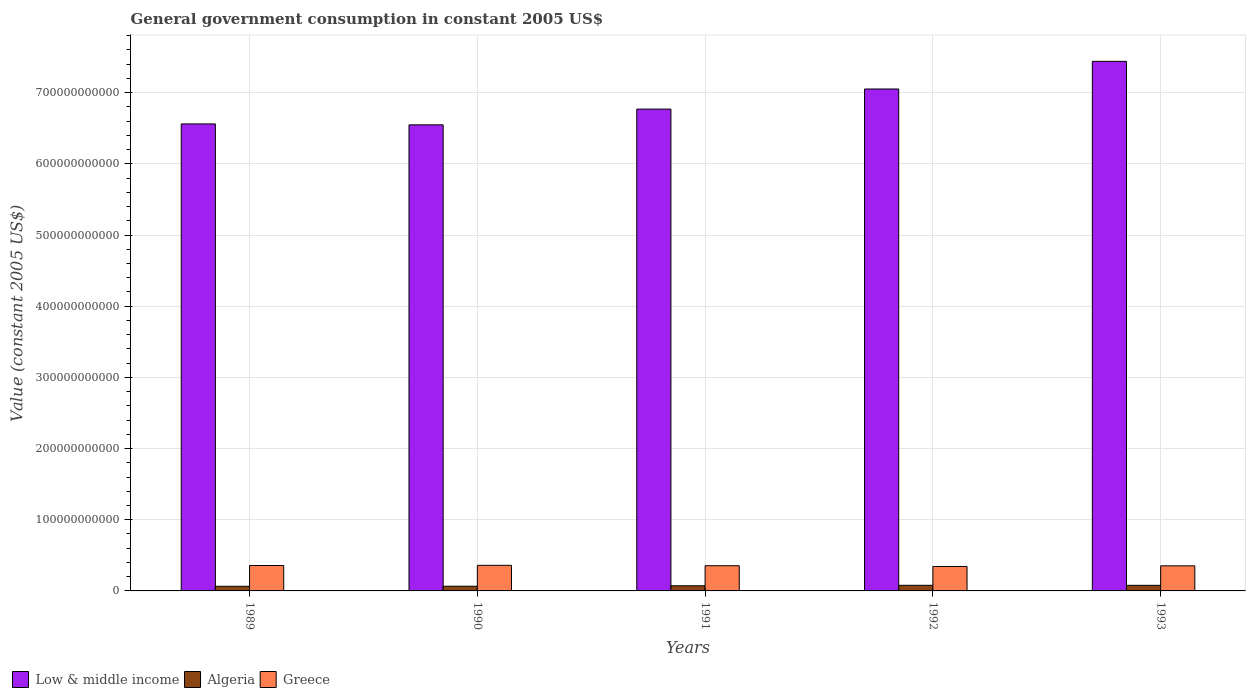Are the number of bars per tick equal to the number of legend labels?
Make the answer very short. Yes. What is the government conusmption in Low & middle income in 1990?
Offer a terse response. 6.55e+11. Across all years, what is the maximum government conusmption in Algeria?
Keep it short and to the point. 7.89e+09. Across all years, what is the minimum government conusmption in Greece?
Your answer should be compact. 3.43e+1. In which year was the government conusmption in Greece maximum?
Provide a short and direct response. 1990. What is the total government conusmption in Algeria in the graph?
Give a very brief answer. 3.61e+1. What is the difference between the government conusmption in Low & middle income in 1989 and that in 1991?
Provide a short and direct response. -2.08e+1. What is the difference between the government conusmption in Algeria in 1993 and the government conusmption in Greece in 1989?
Give a very brief answer. -2.79e+1. What is the average government conusmption in Algeria per year?
Ensure brevity in your answer.  7.22e+09. In the year 1992, what is the difference between the government conusmption in Low & middle income and government conusmption in Algeria?
Keep it short and to the point. 6.97e+11. In how many years, is the government conusmption in Greece greater than 620000000000 US$?
Your response must be concise. 0. What is the ratio of the government conusmption in Algeria in 1989 to that in 1991?
Ensure brevity in your answer.  0.9. Is the difference between the government conusmption in Low & middle income in 1992 and 1993 greater than the difference between the government conusmption in Algeria in 1992 and 1993?
Your response must be concise. No. What is the difference between the highest and the second highest government conusmption in Algeria?
Your response must be concise. 3.16e+07. What is the difference between the highest and the lowest government conusmption in Algeria?
Provide a short and direct response. 1.40e+09. In how many years, is the government conusmption in Low & middle income greater than the average government conusmption in Low & middle income taken over all years?
Provide a short and direct response. 2. What does the 2nd bar from the right in 1991 represents?
Offer a terse response. Algeria. Is it the case that in every year, the sum of the government conusmption in Greece and government conusmption in Algeria is greater than the government conusmption in Low & middle income?
Ensure brevity in your answer.  No. How many bars are there?
Offer a very short reply. 15. How many years are there in the graph?
Keep it short and to the point. 5. What is the difference between two consecutive major ticks on the Y-axis?
Offer a terse response. 1.00e+11. Where does the legend appear in the graph?
Your response must be concise. Bottom left. How many legend labels are there?
Ensure brevity in your answer.  3. How are the legend labels stacked?
Keep it short and to the point. Horizontal. What is the title of the graph?
Provide a short and direct response. General government consumption in constant 2005 US$. Does "Zimbabwe" appear as one of the legend labels in the graph?
Your response must be concise. No. What is the label or title of the Y-axis?
Your answer should be very brief. Value (constant 2005 US$). What is the Value (constant 2005 US$) of Low & middle income in 1989?
Your answer should be very brief. 6.56e+11. What is the Value (constant 2005 US$) in Algeria in 1989?
Give a very brief answer. 6.50e+09. What is the Value (constant 2005 US$) in Greece in 1989?
Offer a very short reply. 3.57e+1. What is the Value (constant 2005 US$) in Low & middle income in 1990?
Offer a very short reply. 6.55e+11. What is the Value (constant 2005 US$) of Algeria in 1990?
Ensure brevity in your answer.  6.60e+09. What is the Value (constant 2005 US$) of Greece in 1990?
Your answer should be compact. 3.59e+1. What is the Value (constant 2005 US$) in Low & middle income in 1991?
Offer a terse response. 6.77e+11. What is the Value (constant 2005 US$) in Algeria in 1991?
Your answer should be compact. 7.22e+09. What is the Value (constant 2005 US$) in Greece in 1991?
Your answer should be very brief. 3.54e+1. What is the Value (constant 2005 US$) in Low & middle income in 1992?
Provide a succinct answer. 7.05e+11. What is the Value (constant 2005 US$) of Algeria in 1992?
Provide a succinct answer. 7.89e+09. What is the Value (constant 2005 US$) of Greece in 1992?
Give a very brief answer. 3.43e+1. What is the Value (constant 2005 US$) of Low & middle income in 1993?
Make the answer very short. 7.44e+11. What is the Value (constant 2005 US$) in Algeria in 1993?
Keep it short and to the point. 7.86e+09. What is the Value (constant 2005 US$) of Greece in 1993?
Your answer should be compact. 3.52e+1. Across all years, what is the maximum Value (constant 2005 US$) in Low & middle income?
Ensure brevity in your answer.  7.44e+11. Across all years, what is the maximum Value (constant 2005 US$) of Algeria?
Give a very brief answer. 7.89e+09. Across all years, what is the maximum Value (constant 2005 US$) in Greece?
Keep it short and to the point. 3.59e+1. Across all years, what is the minimum Value (constant 2005 US$) in Low & middle income?
Your answer should be very brief. 6.55e+11. Across all years, what is the minimum Value (constant 2005 US$) of Algeria?
Ensure brevity in your answer.  6.50e+09. Across all years, what is the minimum Value (constant 2005 US$) of Greece?
Make the answer very short. 3.43e+1. What is the total Value (constant 2005 US$) in Low & middle income in the graph?
Provide a succinct answer. 3.44e+12. What is the total Value (constant 2005 US$) of Algeria in the graph?
Keep it short and to the point. 3.61e+1. What is the total Value (constant 2005 US$) in Greece in the graph?
Ensure brevity in your answer.  1.77e+11. What is the difference between the Value (constant 2005 US$) of Low & middle income in 1989 and that in 1990?
Your response must be concise. 1.29e+09. What is the difference between the Value (constant 2005 US$) in Algeria in 1989 and that in 1990?
Ensure brevity in your answer.  -9.75e+07. What is the difference between the Value (constant 2005 US$) in Greece in 1989 and that in 1990?
Give a very brief answer. -2.14e+08. What is the difference between the Value (constant 2005 US$) in Low & middle income in 1989 and that in 1991?
Ensure brevity in your answer.  -2.08e+1. What is the difference between the Value (constant 2005 US$) in Algeria in 1989 and that in 1991?
Provide a short and direct response. -7.24e+08. What is the difference between the Value (constant 2005 US$) of Greece in 1989 and that in 1991?
Offer a very short reply. 3.25e+08. What is the difference between the Value (constant 2005 US$) of Low & middle income in 1989 and that in 1992?
Your answer should be compact. -4.91e+1. What is the difference between the Value (constant 2005 US$) of Algeria in 1989 and that in 1992?
Offer a terse response. -1.40e+09. What is the difference between the Value (constant 2005 US$) in Greece in 1989 and that in 1992?
Offer a very short reply. 1.39e+09. What is the difference between the Value (constant 2005 US$) of Low & middle income in 1989 and that in 1993?
Your response must be concise. -8.79e+1. What is the difference between the Value (constant 2005 US$) of Algeria in 1989 and that in 1993?
Provide a succinct answer. -1.36e+09. What is the difference between the Value (constant 2005 US$) of Greece in 1989 and that in 1993?
Give a very brief answer. 4.94e+08. What is the difference between the Value (constant 2005 US$) in Low & middle income in 1990 and that in 1991?
Provide a short and direct response. -2.21e+1. What is the difference between the Value (constant 2005 US$) in Algeria in 1990 and that in 1991?
Offer a very short reply. -6.27e+08. What is the difference between the Value (constant 2005 US$) in Greece in 1990 and that in 1991?
Your response must be concise. 5.39e+08. What is the difference between the Value (constant 2005 US$) of Low & middle income in 1990 and that in 1992?
Ensure brevity in your answer.  -5.04e+1. What is the difference between the Value (constant 2005 US$) in Algeria in 1990 and that in 1992?
Offer a terse response. -1.30e+09. What is the difference between the Value (constant 2005 US$) in Greece in 1990 and that in 1992?
Make the answer very short. 1.60e+09. What is the difference between the Value (constant 2005 US$) of Low & middle income in 1990 and that in 1993?
Offer a terse response. -8.92e+1. What is the difference between the Value (constant 2005 US$) in Algeria in 1990 and that in 1993?
Your answer should be compact. -1.27e+09. What is the difference between the Value (constant 2005 US$) in Greece in 1990 and that in 1993?
Your response must be concise. 7.08e+08. What is the difference between the Value (constant 2005 US$) of Low & middle income in 1991 and that in 1992?
Your answer should be compact. -2.83e+1. What is the difference between the Value (constant 2005 US$) of Algeria in 1991 and that in 1992?
Your answer should be very brief. -6.72e+08. What is the difference between the Value (constant 2005 US$) of Greece in 1991 and that in 1992?
Give a very brief answer. 1.06e+09. What is the difference between the Value (constant 2005 US$) of Low & middle income in 1991 and that in 1993?
Ensure brevity in your answer.  -6.71e+1. What is the difference between the Value (constant 2005 US$) of Algeria in 1991 and that in 1993?
Keep it short and to the point. -6.40e+08. What is the difference between the Value (constant 2005 US$) of Greece in 1991 and that in 1993?
Offer a terse response. 1.69e+08. What is the difference between the Value (constant 2005 US$) of Low & middle income in 1992 and that in 1993?
Offer a terse response. -3.88e+1. What is the difference between the Value (constant 2005 US$) of Algeria in 1992 and that in 1993?
Make the answer very short. 3.16e+07. What is the difference between the Value (constant 2005 US$) of Greece in 1992 and that in 1993?
Make the answer very short. -8.93e+08. What is the difference between the Value (constant 2005 US$) in Low & middle income in 1989 and the Value (constant 2005 US$) in Algeria in 1990?
Your answer should be compact. 6.50e+11. What is the difference between the Value (constant 2005 US$) of Low & middle income in 1989 and the Value (constant 2005 US$) of Greece in 1990?
Ensure brevity in your answer.  6.20e+11. What is the difference between the Value (constant 2005 US$) in Algeria in 1989 and the Value (constant 2005 US$) in Greece in 1990?
Give a very brief answer. -2.94e+1. What is the difference between the Value (constant 2005 US$) of Low & middle income in 1989 and the Value (constant 2005 US$) of Algeria in 1991?
Provide a succinct answer. 6.49e+11. What is the difference between the Value (constant 2005 US$) of Low & middle income in 1989 and the Value (constant 2005 US$) of Greece in 1991?
Offer a very short reply. 6.21e+11. What is the difference between the Value (constant 2005 US$) of Algeria in 1989 and the Value (constant 2005 US$) of Greece in 1991?
Give a very brief answer. -2.89e+1. What is the difference between the Value (constant 2005 US$) in Low & middle income in 1989 and the Value (constant 2005 US$) in Algeria in 1992?
Your answer should be compact. 6.48e+11. What is the difference between the Value (constant 2005 US$) in Low & middle income in 1989 and the Value (constant 2005 US$) in Greece in 1992?
Offer a terse response. 6.22e+11. What is the difference between the Value (constant 2005 US$) of Algeria in 1989 and the Value (constant 2005 US$) of Greece in 1992?
Give a very brief answer. -2.78e+1. What is the difference between the Value (constant 2005 US$) of Low & middle income in 1989 and the Value (constant 2005 US$) of Algeria in 1993?
Make the answer very short. 6.48e+11. What is the difference between the Value (constant 2005 US$) of Low & middle income in 1989 and the Value (constant 2005 US$) of Greece in 1993?
Your response must be concise. 6.21e+11. What is the difference between the Value (constant 2005 US$) in Algeria in 1989 and the Value (constant 2005 US$) in Greece in 1993?
Your answer should be very brief. -2.87e+1. What is the difference between the Value (constant 2005 US$) in Low & middle income in 1990 and the Value (constant 2005 US$) in Algeria in 1991?
Your answer should be very brief. 6.48e+11. What is the difference between the Value (constant 2005 US$) in Low & middle income in 1990 and the Value (constant 2005 US$) in Greece in 1991?
Offer a terse response. 6.19e+11. What is the difference between the Value (constant 2005 US$) in Algeria in 1990 and the Value (constant 2005 US$) in Greece in 1991?
Your answer should be compact. -2.88e+1. What is the difference between the Value (constant 2005 US$) of Low & middle income in 1990 and the Value (constant 2005 US$) of Algeria in 1992?
Your response must be concise. 6.47e+11. What is the difference between the Value (constant 2005 US$) of Low & middle income in 1990 and the Value (constant 2005 US$) of Greece in 1992?
Give a very brief answer. 6.20e+11. What is the difference between the Value (constant 2005 US$) in Algeria in 1990 and the Value (constant 2005 US$) in Greece in 1992?
Keep it short and to the point. -2.78e+1. What is the difference between the Value (constant 2005 US$) in Low & middle income in 1990 and the Value (constant 2005 US$) in Algeria in 1993?
Offer a terse response. 6.47e+11. What is the difference between the Value (constant 2005 US$) in Low & middle income in 1990 and the Value (constant 2005 US$) in Greece in 1993?
Your answer should be compact. 6.20e+11. What is the difference between the Value (constant 2005 US$) in Algeria in 1990 and the Value (constant 2005 US$) in Greece in 1993?
Keep it short and to the point. -2.86e+1. What is the difference between the Value (constant 2005 US$) in Low & middle income in 1991 and the Value (constant 2005 US$) in Algeria in 1992?
Offer a very short reply. 6.69e+11. What is the difference between the Value (constant 2005 US$) in Low & middle income in 1991 and the Value (constant 2005 US$) in Greece in 1992?
Your response must be concise. 6.43e+11. What is the difference between the Value (constant 2005 US$) in Algeria in 1991 and the Value (constant 2005 US$) in Greece in 1992?
Make the answer very short. -2.71e+1. What is the difference between the Value (constant 2005 US$) of Low & middle income in 1991 and the Value (constant 2005 US$) of Algeria in 1993?
Your response must be concise. 6.69e+11. What is the difference between the Value (constant 2005 US$) of Low & middle income in 1991 and the Value (constant 2005 US$) of Greece in 1993?
Offer a very short reply. 6.42e+11. What is the difference between the Value (constant 2005 US$) of Algeria in 1991 and the Value (constant 2005 US$) of Greece in 1993?
Offer a very short reply. -2.80e+1. What is the difference between the Value (constant 2005 US$) in Low & middle income in 1992 and the Value (constant 2005 US$) in Algeria in 1993?
Offer a very short reply. 6.97e+11. What is the difference between the Value (constant 2005 US$) of Low & middle income in 1992 and the Value (constant 2005 US$) of Greece in 1993?
Ensure brevity in your answer.  6.70e+11. What is the difference between the Value (constant 2005 US$) in Algeria in 1992 and the Value (constant 2005 US$) in Greece in 1993?
Your answer should be compact. -2.73e+1. What is the average Value (constant 2005 US$) in Low & middle income per year?
Keep it short and to the point. 6.87e+11. What is the average Value (constant 2005 US$) in Algeria per year?
Provide a short and direct response. 7.22e+09. What is the average Value (constant 2005 US$) of Greece per year?
Give a very brief answer. 3.53e+1. In the year 1989, what is the difference between the Value (constant 2005 US$) in Low & middle income and Value (constant 2005 US$) in Algeria?
Make the answer very short. 6.50e+11. In the year 1989, what is the difference between the Value (constant 2005 US$) of Low & middle income and Value (constant 2005 US$) of Greece?
Ensure brevity in your answer.  6.20e+11. In the year 1989, what is the difference between the Value (constant 2005 US$) in Algeria and Value (constant 2005 US$) in Greece?
Your response must be concise. -2.92e+1. In the year 1990, what is the difference between the Value (constant 2005 US$) in Low & middle income and Value (constant 2005 US$) in Algeria?
Provide a short and direct response. 6.48e+11. In the year 1990, what is the difference between the Value (constant 2005 US$) of Low & middle income and Value (constant 2005 US$) of Greece?
Your response must be concise. 6.19e+11. In the year 1990, what is the difference between the Value (constant 2005 US$) of Algeria and Value (constant 2005 US$) of Greece?
Your answer should be very brief. -2.94e+1. In the year 1991, what is the difference between the Value (constant 2005 US$) of Low & middle income and Value (constant 2005 US$) of Algeria?
Provide a succinct answer. 6.70e+11. In the year 1991, what is the difference between the Value (constant 2005 US$) of Low & middle income and Value (constant 2005 US$) of Greece?
Your response must be concise. 6.42e+11. In the year 1991, what is the difference between the Value (constant 2005 US$) in Algeria and Value (constant 2005 US$) in Greece?
Provide a succinct answer. -2.82e+1. In the year 1992, what is the difference between the Value (constant 2005 US$) in Low & middle income and Value (constant 2005 US$) in Algeria?
Ensure brevity in your answer.  6.97e+11. In the year 1992, what is the difference between the Value (constant 2005 US$) in Low & middle income and Value (constant 2005 US$) in Greece?
Keep it short and to the point. 6.71e+11. In the year 1992, what is the difference between the Value (constant 2005 US$) of Algeria and Value (constant 2005 US$) of Greece?
Keep it short and to the point. -2.65e+1. In the year 1993, what is the difference between the Value (constant 2005 US$) of Low & middle income and Value (constant 2005 US$) of Algeria?
Offer a very short reply. 7.36e+11. In the year 1993, what is the difference between the Value (constant 2005 US$) in Low & middle income and Value (constant 2005 US$) in Greece?
Give a very brief answer. 7.09e+11. In the year 1993, what is the difference between the Value (constant 2005 US$) of Algeria and Value (constant 2005 US$) of Greece?
Provide a succinct answer. -2.74e+1. What is the ratio of the Value (constant 2005 US$) of Low & middle income in 1989 to that in 1990?
Give a very brief answer. 1. What is the ratio of the Value (constant 2005 US$) in Algeria in 1989 to that in 1990?
Offer a very short reply. 0.99. What is the ratio of the Value (constant 2005 US$) in Greece in 1989 to that in 1990?
Provide a succinct answer. 0.99. What is the ratio of the Value (constant 2005 US$) of Low & middle income in 1989 to that in 1991?
Offer a terse response. 0.97. What is the ratio of the Value (constant 2005 US$) in Algeria in 1989 to that in 1991?
Ensure brevity in your answer.  0.9. What is the ratio of the Value (constant 2005 US$) of Greece in 1989 to that in 1991?
Ensure brevity in your answer.  1.01. What is the ratio of the Value (constant 2005 US$) of Low & middle income in 1989 to that in 1992?
Give a very brief answer. 0.93. What is the ratio of the Value (constant 2005 US$) in Algeria in 1989 to that in 1992?
Offer a terse response. 0.82. What is the ratio of the Value (constant 2005 US$) in Greece in 1989 to that in 1992?
Provide a succinct answer. 1.04. What is the ratio of the Value (constant 2005 US$) in Low & middle income in 1989 to that in 1993?
Your response must be concise. 0.88. What is the ratio of the Value (constant 2005 US$) in Algeria in 1989 to that in 1993?
Your response must be concise. 0.83. What is the ratio of the Value (constant 2005 US$) of Low & middle income in 1990 to that in 1991?
Make the answer very short. 0.97. What is the ratio of the Value (constant 2005 US$) of Algeria in 1990 to that in 1991?
Provide a short and direct response. 0.91. What is the ratio of the Value (constant 2005 US$) of Greece in 1990 to that in 1991?
Offer a terse response. 1.02. What is the ratio of the Value (constant 2005 US$) in Low & middle income in 1990 to that in 1992?
Offer a terse response. 0.93. What is the ratio of the Value (constant 2005 US$) of Algeria in 1990 to that in 1992?
Offer a terse response. 0.84. What is the ratio of the Value (constant 2005 US$) in Greece in 1990 to that in 1992?
Your answer should be compact. 1.05. What is the ratio of the Value (constant 2005 US$) of Low & middle income in 1990 to that in 1993?
Your answer should be compact. 0.88. What is the ratio of the Value (constant 2005 US$) of Algeria in 1990 to that in 1993?
Offer a very short reply. 0.84. What is the ratio of the Value (constant 2005 US$) of Greece in 1990 to that in 1993?
Your answer should be compact. 1.02. What is the ratio of the Value (constant 2005 US$) in Low & middle income in 1991 to that in 1992?
Offer a terse response. 0.96. What is the ratio of the Value (constant 2005 US$) in Algeria in 1991 to that in 1992?
Give a very brief answer. 0.91. What is the ratio of the Value (constant 2005 US$) in Greece in 1991 to that in 1992?
Make the answer very short. 1.03. What is the ratio of the Value (constant 2005 US$) of Low & middle income in 1991 to that in 1993?
Make the answer very short. 0.91. What is the ratio of the Value (constant 2005 US$) in Algeria in 1991 to that in 1993?
Offer a terse response. 0.92. What is the ratio of the Value (constant 2005 US$) of Greece in 1991 to that in 1993?
Provide a short and direct response. 1. What is the ratio of the Value (constant 2005 US$) in Low & middle income in 1992 to that in 1993?
Offer a very short reply. 0.95. What is the ratio of the Value (constant 2005 US$) in Algeria in 1992 to that in 1993?
Make the answer very short. 1. What is the ratio of the Value (constant 2005 US$) of Greece in 1992 to that in 1993?
Provide a short and direct response. 0.97. What is the difference between the highest and the second highest Value (constant 2005 US$) of Low & middle income?
Provide a short and direct response. 3.88e+1. What is the difference between the highest and the second highest Value (constant 2005 US$) of Algeria?
Your answer should be compact. 3.16e+07. What is the difference between the highest and the second highest Value (constant 2005 US$) of Greece?
Offer a terse response. 2.14e+08. What is the difference between the highest and the lowest Value (constant 2005 US$) in Low & middle income?
Provide a short and direct response. 8.92e+1. What is the difference between the highest and the lowest Value (constant 2005 US$) of Algeria?
Provide a succinct answer. 1.40e+09. What is the difference between the highest and the lowest Value (constant 2005 US$) in Greece?
Keep it short and to the point. 1.60e+09. 